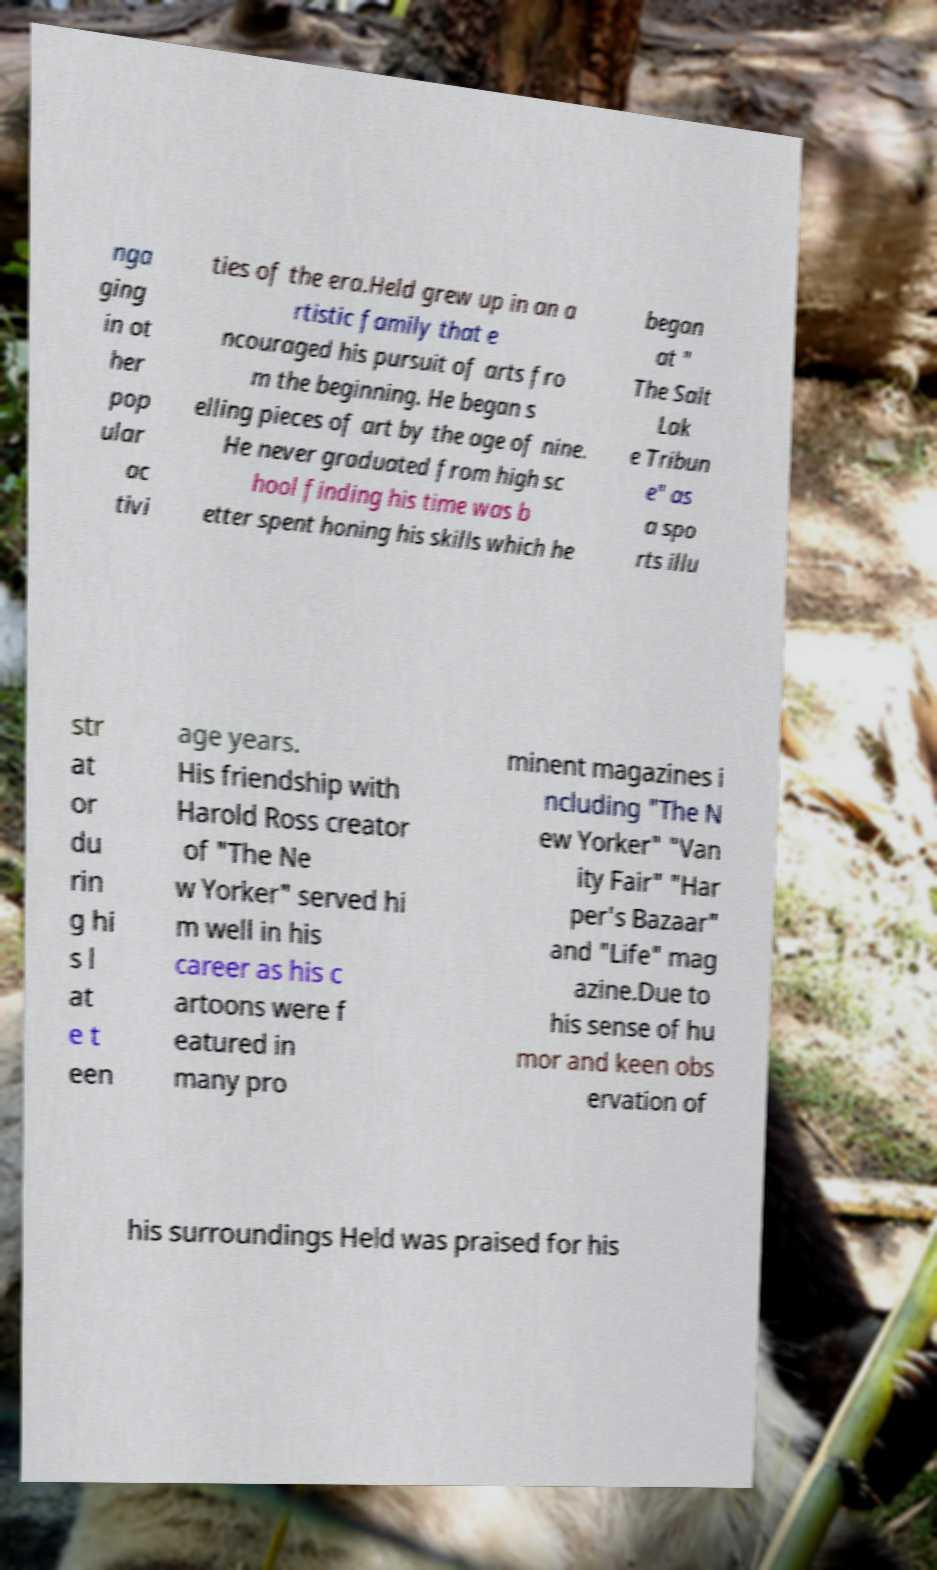Could you assist in decoding the text presented in this image and type it out clearly? nga ging in ot her pop ular ac tivi ties of the era.Held grew up in an a rtistic family that e ncouraged his pursuit of arts fro m the beginning. He began s elling pieces of art by the age of nine. He never graduated from high sc hool finding his time was b etter spent honing his skills which he began at " The Salt Lak e Tribun e" as a spo rts illu str at or du rin g hi s l at e t een age years. His friendship with Harold Ross creator of "The Ne w Yorker" served hi m well in his career as his c artoons were f eatured in many pro minent magazines i ncluding "The N ew Yorker" "Van ity Fair" "Har per's Bazaar" and "Life" mag azine.Due to his sense of hu mor and keen obs ervation of his surroundings Held was praised for his 